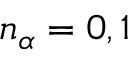Convert formula to latex. <formula><loc_0><loc_0><loc_500><loc_500>n _ { \alpha } = 0 , 1</formula> 